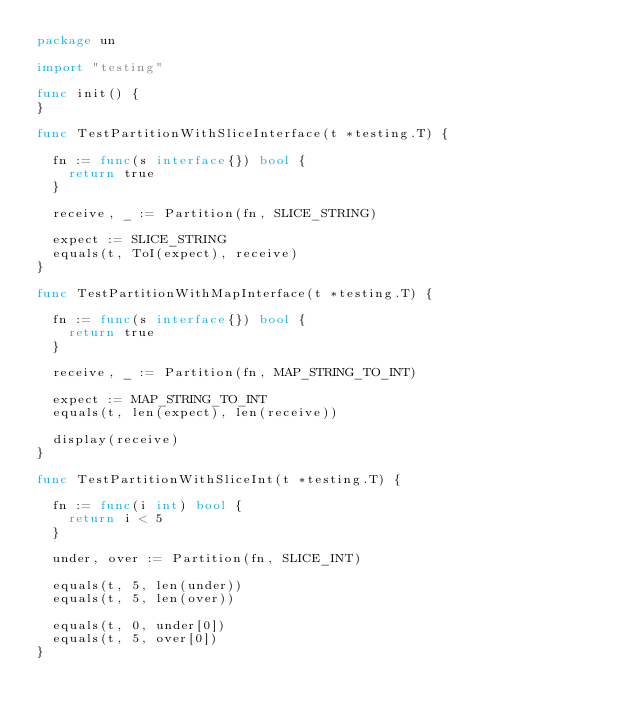<code> <loc_0><loc_0><loc_500><loc_500><_Go_>package un

import "testing"

func init() {
}

func TestPartitionWithSliceInterface(t *testing.T) {

	fn := func(s interface{}) bool {
		return true
	}

	receive, _ := Partition(fn, SLICE_STRING)

	expect := SLICE_STRING
	equals(t, ToI(expect), receive)
}

func TestPartitionWithMapInterface(t *testing.T) {

	fn := func(s interface{}) bool {
		return true
	}

	receive, _ := Partition(fn, MAP_STRING_TO_INT)

	expect := MAP_STRING_TO_INT
	equals(t, len(expect), len(receive))

	display(receive)
}

func TestPartitionWithSliceInt(t *testing.T) {

	fn := func(i int) bool {
		return i < 5
	}

	under, over := Partition(fn, SLICE_INT)

	equals(t, 5, len(under))
	equals(t, 5, len(over))

	equals(t, 0, under[0])
	equals(t, 5, over[0])
}
</code> 